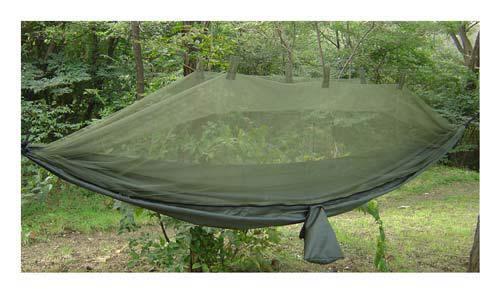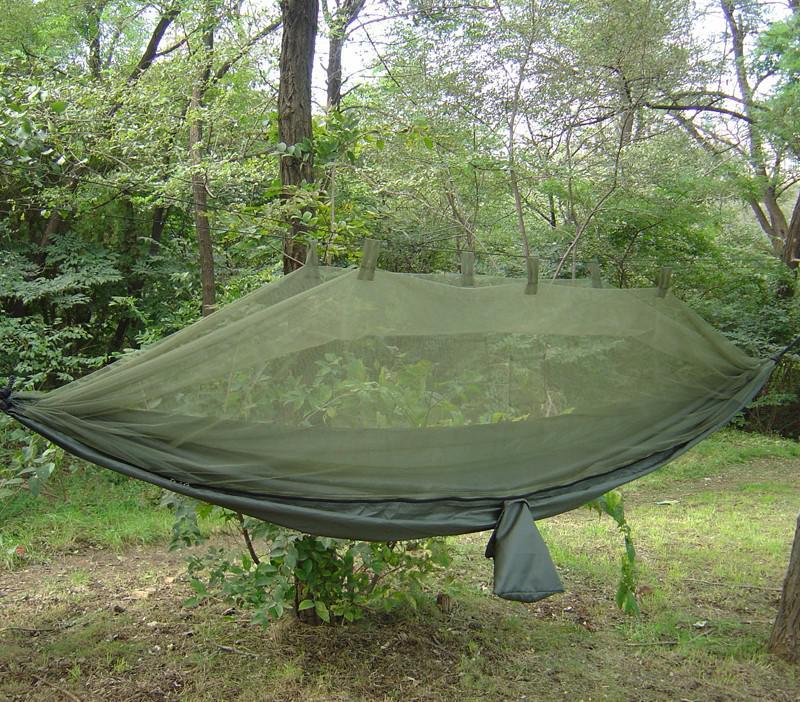The first image is the image on the left, the second image is the image on the right. Analyze the images presented: Is the assertion "A person can be seen in one image of a hanging hammock with netting cover." valid? Answer yes or no. No. 